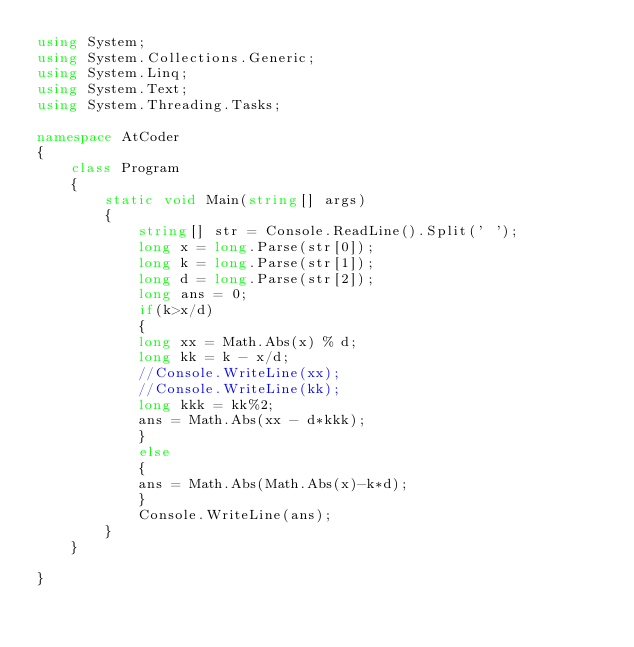Convert code to text. <code><loc_0><loc_0><loc_500><loc_500><_C#_>using System;
using System.Collections.Generic;
using System.Linq;
using System.Text;
using System.Threading.Tasks;
 
namespace AtCoder
{
    class Program
    {
        static void Main(string[] args)
        {
            string[] str = Console.ReadLine().Split(' ');
            long x = long.Parse(str[0]);
            long k = long.Parse(str[1]);
            long d = long.Parse(str[2]);
            long ans = 0;
            if(k>x/d)
            {
            long xx = Math.Abs(x) % d;
            long kk = k - x/d;
            //Console.WriteLine(xx);
            //Console.WriteLine(kk);
            long kkk = kk%2;
            ans = Math.Abs(xx - d*kkk);
            }
            else
            {
            ans = Math.Abs(Math.Abs(x)-k*d);
            }
            Console.WriteLine(ans);
        }
    }
    
}</code> 